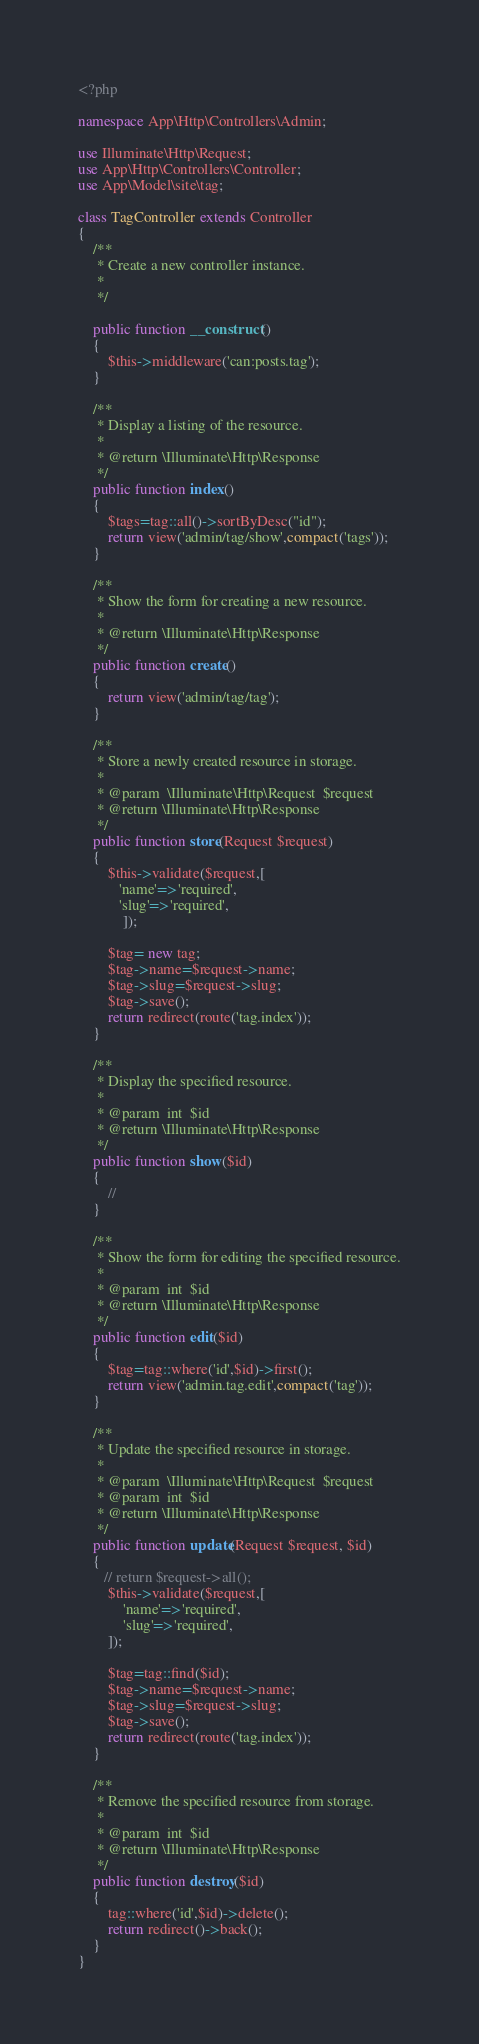<code> <loc_0><loc_0><loc_500><loc_500><_PHP_><?php

namespace App\Http\Controllers\Admin;

use Illuminate\Http\Request;
use App\Http\Controllers\Controller;
use App\Model\site\tag;

class TagController extends Controller
{
    /**
     * Create a new controller instance.
     *
     */

    public function __construct()
    {
        $this->middleware('can:posts.tag');
    }

    /**
     * Display a listing of the resource.
     *
     * @return \Illuminate\Http\Response
     */
    public function index()
    {
        $tags=tag::all()->sortByDesc("id");
        return view('admin/tag/show',compact('tags'));
    }

    /**
     * Show the form for creating a new resource.
     *
     * @return \Illuminate\Http\Response
     */
    public function create()
    {
        return view('admin/tag/tag');
    }

    /**
     * Store a newly created resource in storage.
     *
     * @param  \Illuminate\Http\Request  $request
     * @return \Illuminate\Http\Response
     */
    public function store(Request $request)
    {
        $this->validate($request,[
           'name'=>'required',
           'slug'=>'required',
            ]);

        $tag= new tag;
        $tag->name=$request->name;
        $tag->slug=$request->slug;
        $tag->save();
        return redirect(route('tag.index'));
    }

    /**
     * Display the specified resource.
     *
     * @param  int  $id
     * @return \Illuminate\Http\Response
     */
    public function show($id)
    {
        //
    }

    /**
     * Show the form for editing the specified resource.
     *
     * @param  int  $id
     * @return \Illuminate\Http\Response
     */
    public function edit($id)
    {
        $tag=tag::where('id',$id)->first();
        return view('admin.tag.edit',compact('tag'));
    }

    /**
     * Update the specified resource in storage.
     *
     * @param  \Illuminate\Http\Request  $request
     * @param  int  $id
     * @return \Illuminate\Http\Response
     */
    public function update(Request $request, $id)
    {
       // return $request->all();
        $this->validate($request,[
            'name'=>'required',
            'slug'=>'required',
        ]);

        $tag=tag::find($id);
        $tag->name=$request->name;
        $tag->slug=$request->slug;
        $tag->save();
        return redirect(route('tag.index'));
    }

    /**
     * Remove the specified resource from storage.
     *
     * @param  int  $id
     * @return \Illuminate\Http\Response
     */
    public function destroy($id)
    {
        tag::where('id',$id)->delete();
        return redirect()->back();
    }
}
</code> 